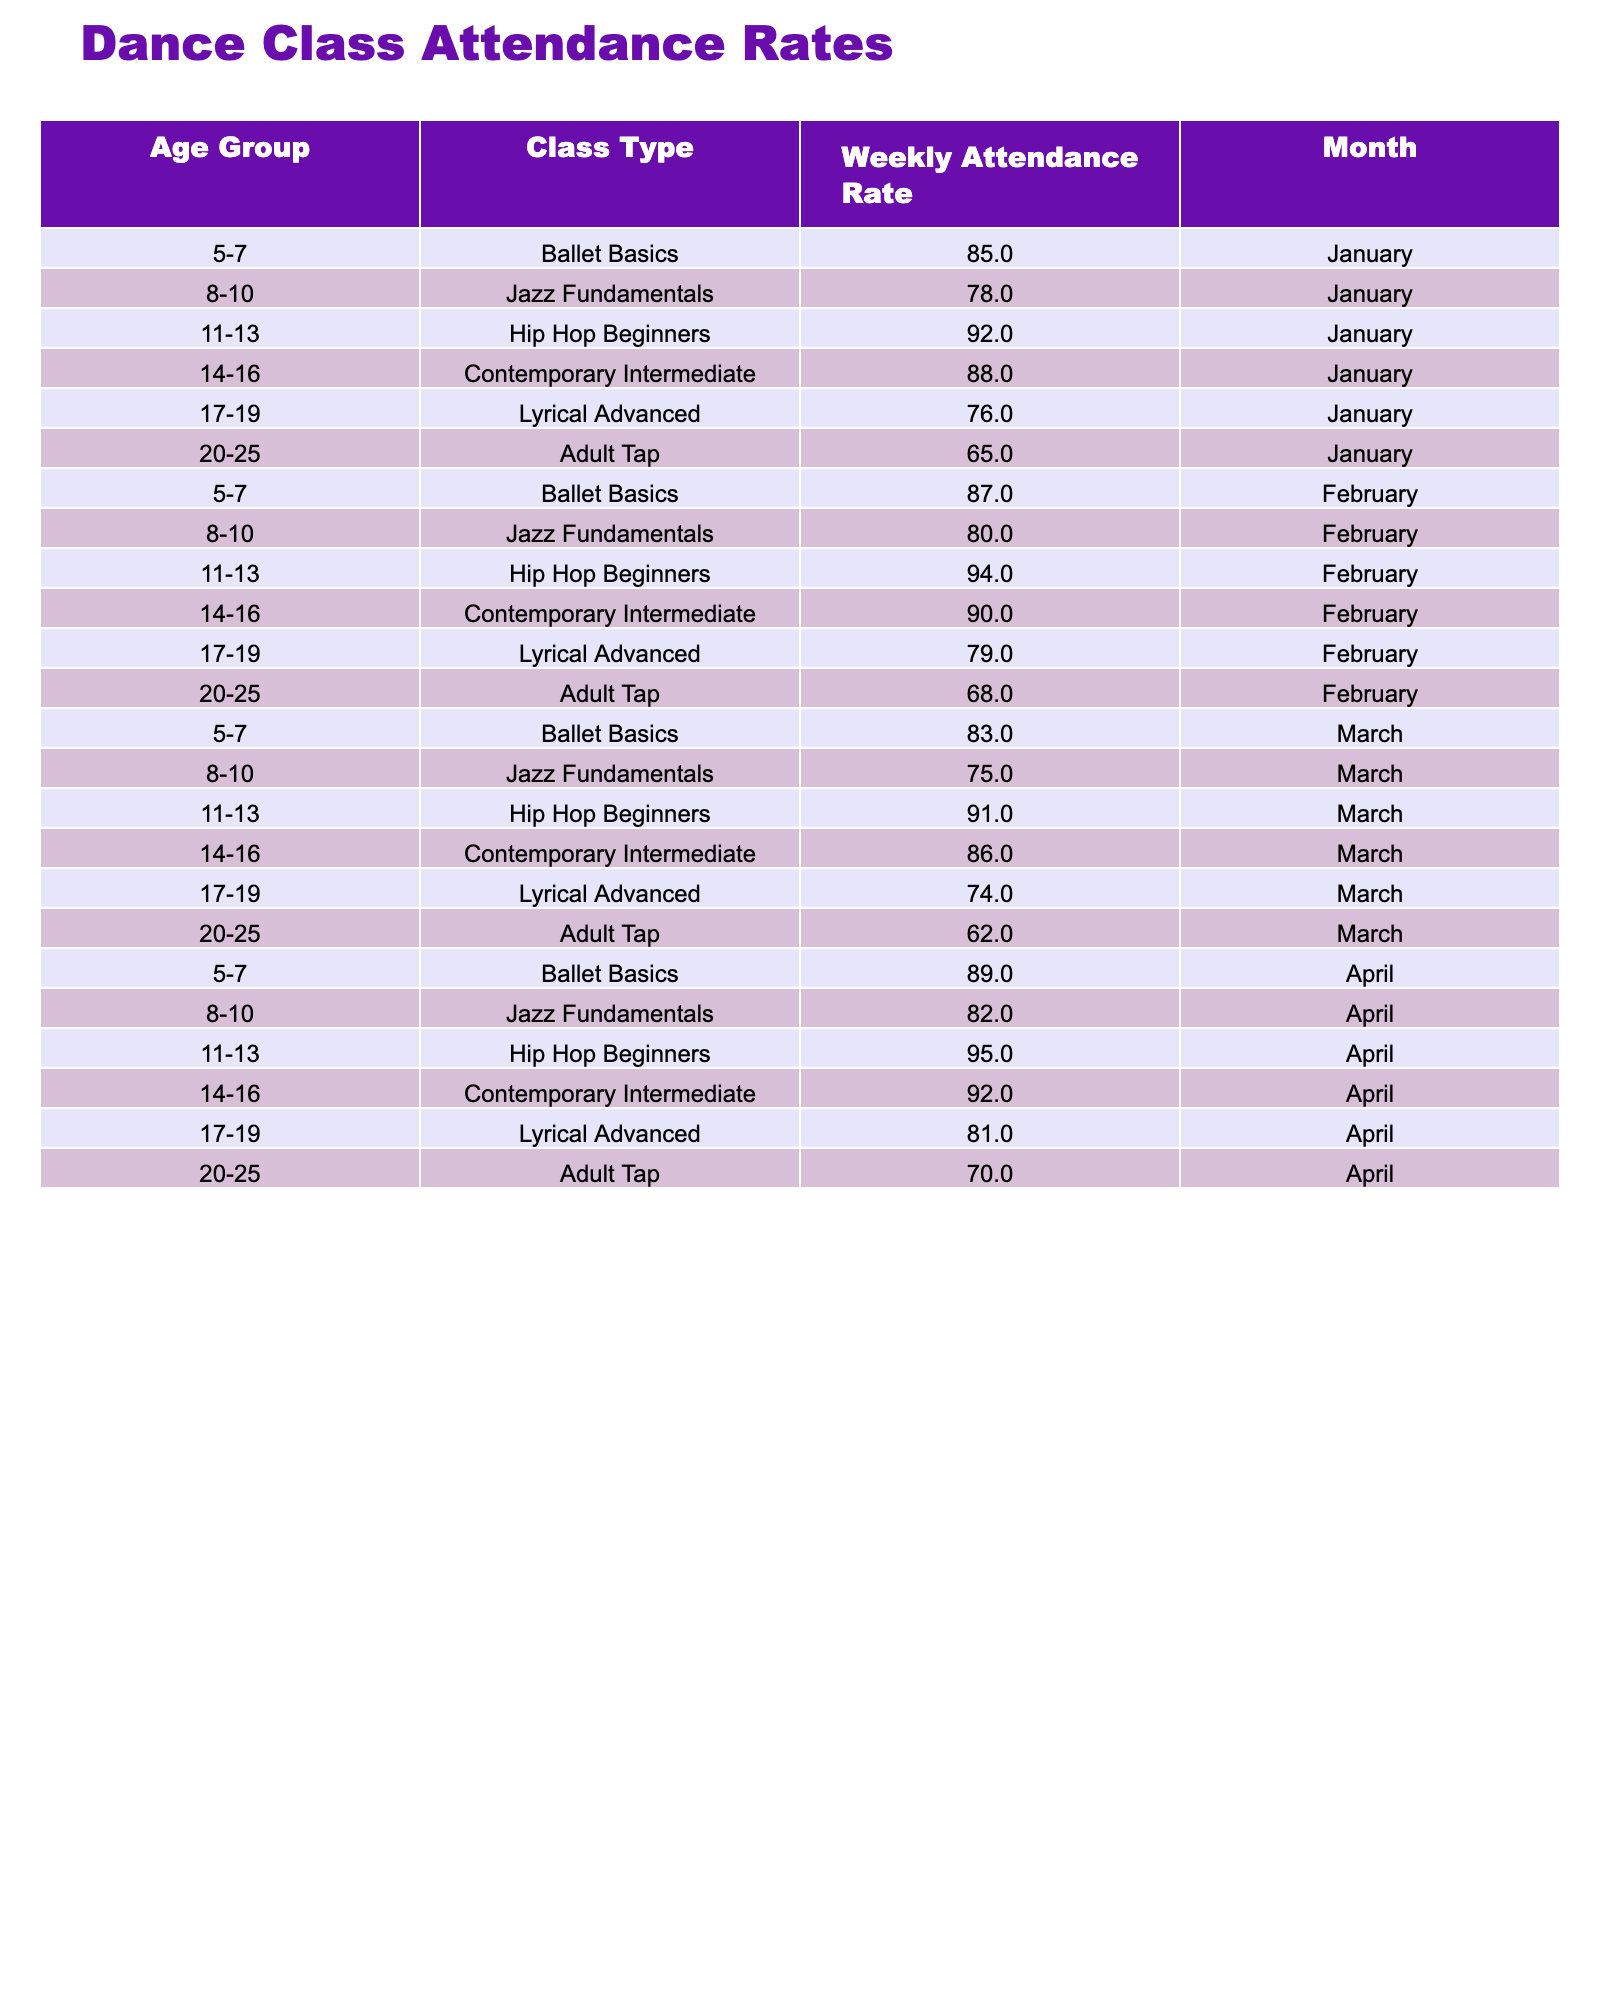What is the weekly attendance rate for the 11-13 age group in April? Referring to the table, for the age group 11-13 in April, the attendance rate listed is 95%.
Answer: 95% What is the overall attendance rate for the 20-25 age group across all months? The attendance rates for the 20-25 age group are 65%, 68%, 62%, and 70%. Adding those gives 65 + 68 + 62 + 70 = 265. There are 4 months, so the average is 265/4 = 66.25%.
Answer: 66.25% Was the attendance rate for the 14-16 age group higher in February or in March? In February, the attendance rate for the 14-16 age group is 90%, and in March, it is 86%. Since 90% is greater than 86%, the rate was higher in February.
Answer: Yes Which age group had the highest weekly attendance rate in January? Looking at the table, the attendance rates for January are 85%, 78%, 92%, 88%, 76%, and 65% for age groups 5-7, 8-10, 11-13, 14-16, 17-19, and 20-25 respectively. The highest is 92% for the 11-13 age group.
Answer: 11-13 age group What is the difference between the highest and lowest attendance rates for all age groups in February? In February, the highest attendance rate is 94% (11-13 age group) and the lowest is 68% (20-25 age group). The difference is 94 - 68 = 26%.
Answer: 26% Which month showed the greatest increase in attendance rates for the 5-7 age group? The attendance rates for the 5-7 age group are 85% (January), 87% (February), 83% (March), and 89% (April). The greatest increase occurs from January to February, which is an increase of 87% - 85% = 2%.
Answer: February What is the average attendance rate for the 8-10 age group over the four months? The rates for the 8-10 age group are 78%, 80%, 75%, and 82%. Summing these gives 78 + 80 + 75 + 82 = 315. There are 4 months, so the average is 315/4 = 78.75%.
Answer: 78.75% Did the attendance rate for the 17-19 age group increase or decrease from March to April? In March, the attendance rate for the 17-19 age group is 74%, and in April it is 81%. Since 81% is greater than 74%, it increased.
Answer: Increased Which class type had the most consistent attendance rates across the months? The class types' attendance rates for each month reveal fluctuations, but if we consider the 8-10 age group (78%, 80%, 75%, 82%), it shows less variance than other age groups.
Answer: 8-10 age group What is the average attendance rate for all age groups and all months combined? The total attendance rates across all entries are 85%, 78%, 92%, 88%, 76%, 65%, 87%, 80%, 94%, 90%, 79%, 68%, 83%, 75%, 91%, 86%, 74%, 62%, 89%, 82%, 95%, 92%, 81%, 70%. The total is 1988%. There are 24 entries, so the average is 1988/24 = 82.83%.
Answer: 82.83% 